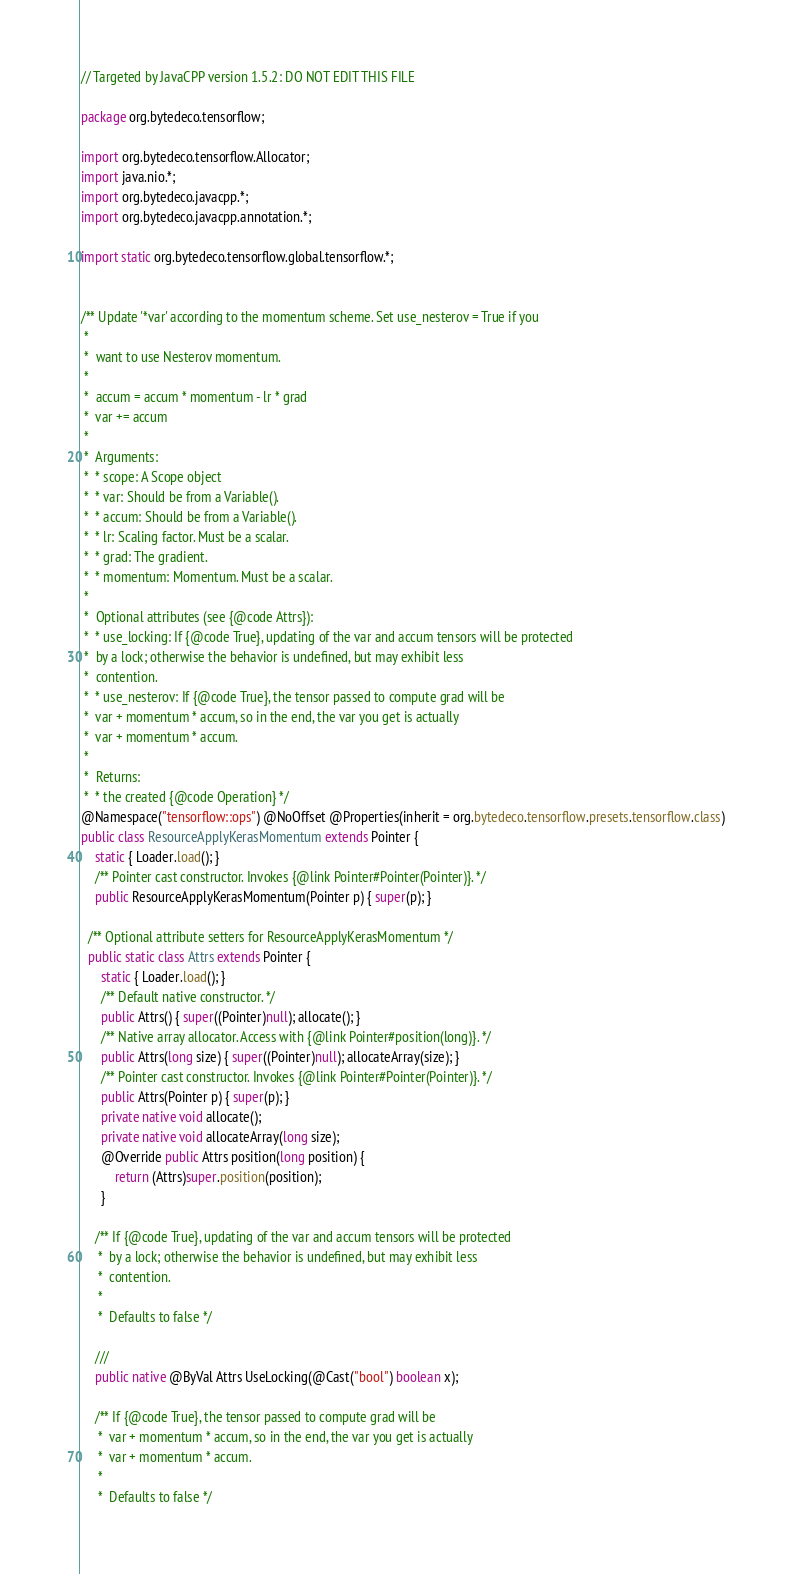<code> <loc_0><loc_0><loc_500><loc_500><_Java_>// Targeted by JavaCPP version 1.5.2: DO NOT EDIT THIS FILE

package org.bytedeco.tensorflow;

import org.bytedeco.tensorflow.Allocator;
import java.nio.*;
import org.bytedeco.javacpp.*;
import org.bytedeco.javacpp.annotation.*;

import static org.bytedeco.tensorflow.global.tensorflow.*;


/** Update '*var' according to the momentum scheme. Set use_nesterov = True if you
 * 
 *  want to use Nesterov momentum.
 * 
 *  accum = accum * momentum - lr * grad
 *  var += accum
 * 
 *  Arguments:
 *  * scope: A Scope object
 *  * var: Should be from a Variable().
 *  * accum: Should be from a Variable().
 *  * lr: Scaling factor. Must be a scalar.
 *  * grad: The gradient.
 *  * momentum: Momentum. Must be a scalar.
 * 
 *  Optional attributes (see {@code Attrs}):
 *  * use_locking: If {@code True}, updating of the var and accum tensors will be protected
 *  by a lock; otherwise the behavior is undefined, but may exhibit less
 *  contention.
 *  * use_nesterov: If {@code True}, the tensor passed to compute grad will be
 *  var + momentum * accum, so in the end, the var you get is actually
 *  var + momentum * accum.
 * 
 *  Returns:
 *  * the created {@code Operation} */
@Namespace("tensorflow::ops") @NoOffset @Properties(inherit = org.bytedeco.tensorflow.presets.tensorflow.class)
public class ResourceApplyKerasMomentum extends Pointer {
    static { Loader.load(); }
    /** Pointer cast constructor. Invokes {@link Pointer#Pointer(Pointer)}. */
    public ResourceApplyKerasMomentum(Pointer p) { super(p); }

  /** Optional attribute setters for ResourceApplyKerasMomentum */
  public static class Attrs extends Pointer {
      static { Loader.load(); }
      /** Default native constructor. */
      public Attrs() { super((Pointer)null); allocate(); }
      /** Native array allocator. Access with {@link Pointer#position(long)}. */
      public Attrs(long size) { super((Pointer)null); allocateArray(size); }
      /** Pointer cast constructor. Invokes {@link Pointer#Pointer(Pointer)}. */
      public Attrs(Pointer p) { super(p); }
      private native void allocate();
      private native void allocateArray(long size);
      @Override public Attrs position(long position) {
          return (Attrs)super.position(position);
      }
  
    /** If {@code True}, updating of the var and accum tensors will be protected
     *  by a lock; otherwise the behavior is undefined, but may exhibit less
     *  contention.
     * 
     *  Defaults to false */
    
    ///
    public native @ByVal Attrs UseLocking(@Cast("bool") boolean x);

    /** If {@code True}, the tensor passed to compute grad will be
     *  var + momentum * accum, so in the end, the var you get is actually
     *  var + momentum * accum.
     * 
     *  Defaults to false */</code> 